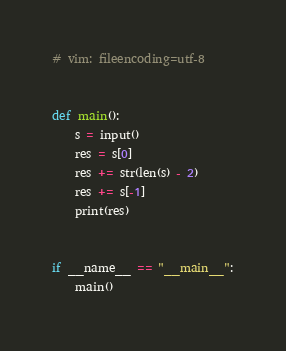Convert code to text. <code><loc_0><loc_0><loc_500><loc_500><_Python_># vim: fileencoding=utf-8


def main():
    s = input()
    res = s[0]
    res += str(len(s) - 2)
    res += s[-1]
    print(res)


if __name__ == "__main__":
    main()
</code> 